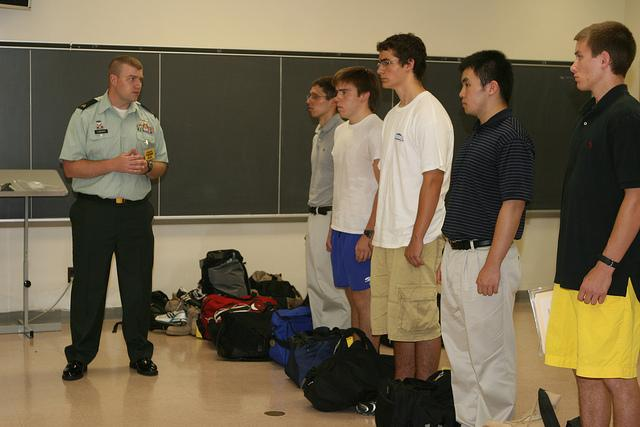What role are persons out of uniform here in? recruit 